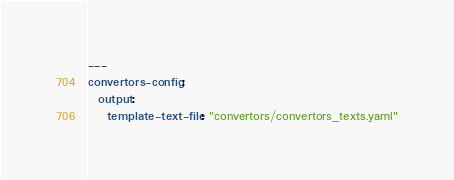<code> <loc_0><loc_0><loc_500><loc_500><_YAML_>---
convertors-config:
  output:
    template-text-file: "convertors/convertors_texts.yaml"</code> 